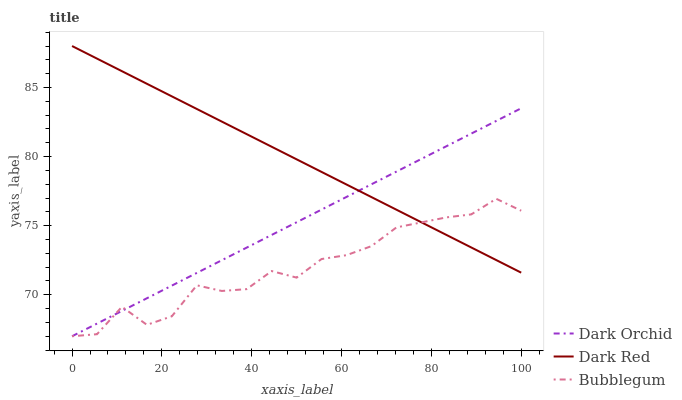Does Bubblegum have the minimum area under the curve?
Answer yes or no. Yes. Does Dark Red have the maximum area under the curve?
Answer yes or no. Yes. Does Dark Orchid have the minimum area under the curve?
Answer yes or no. No. Does Dark Orchid have the maximum area under the curve?
Answer yes or no. No. Is Dark Red the smoothest?
Answer yes or no. Yes. Is Bubblegum the roughest?
Answer yes or no. Yes. Is Dark Orchid the smoothest?
Answer yes or no. No. Is Dark Orchid the roughest?
Answer yes or no. No. Does Bubblegum have the lowest value?
Answer yes or no. Yes. Does Dark Red have the highest value?
Answer yes or no. Yes. Does Dark Orchid have the highest value?
Answer yes or no. No. Does Dark Red intersect Dark Orchid?
Answer yes or no. Yes. Is Dark Red less than Dark Orchid?
Answer yes or no. No. Is Dark Red greater than Dark Orchid?
Answer yes or no. No. 